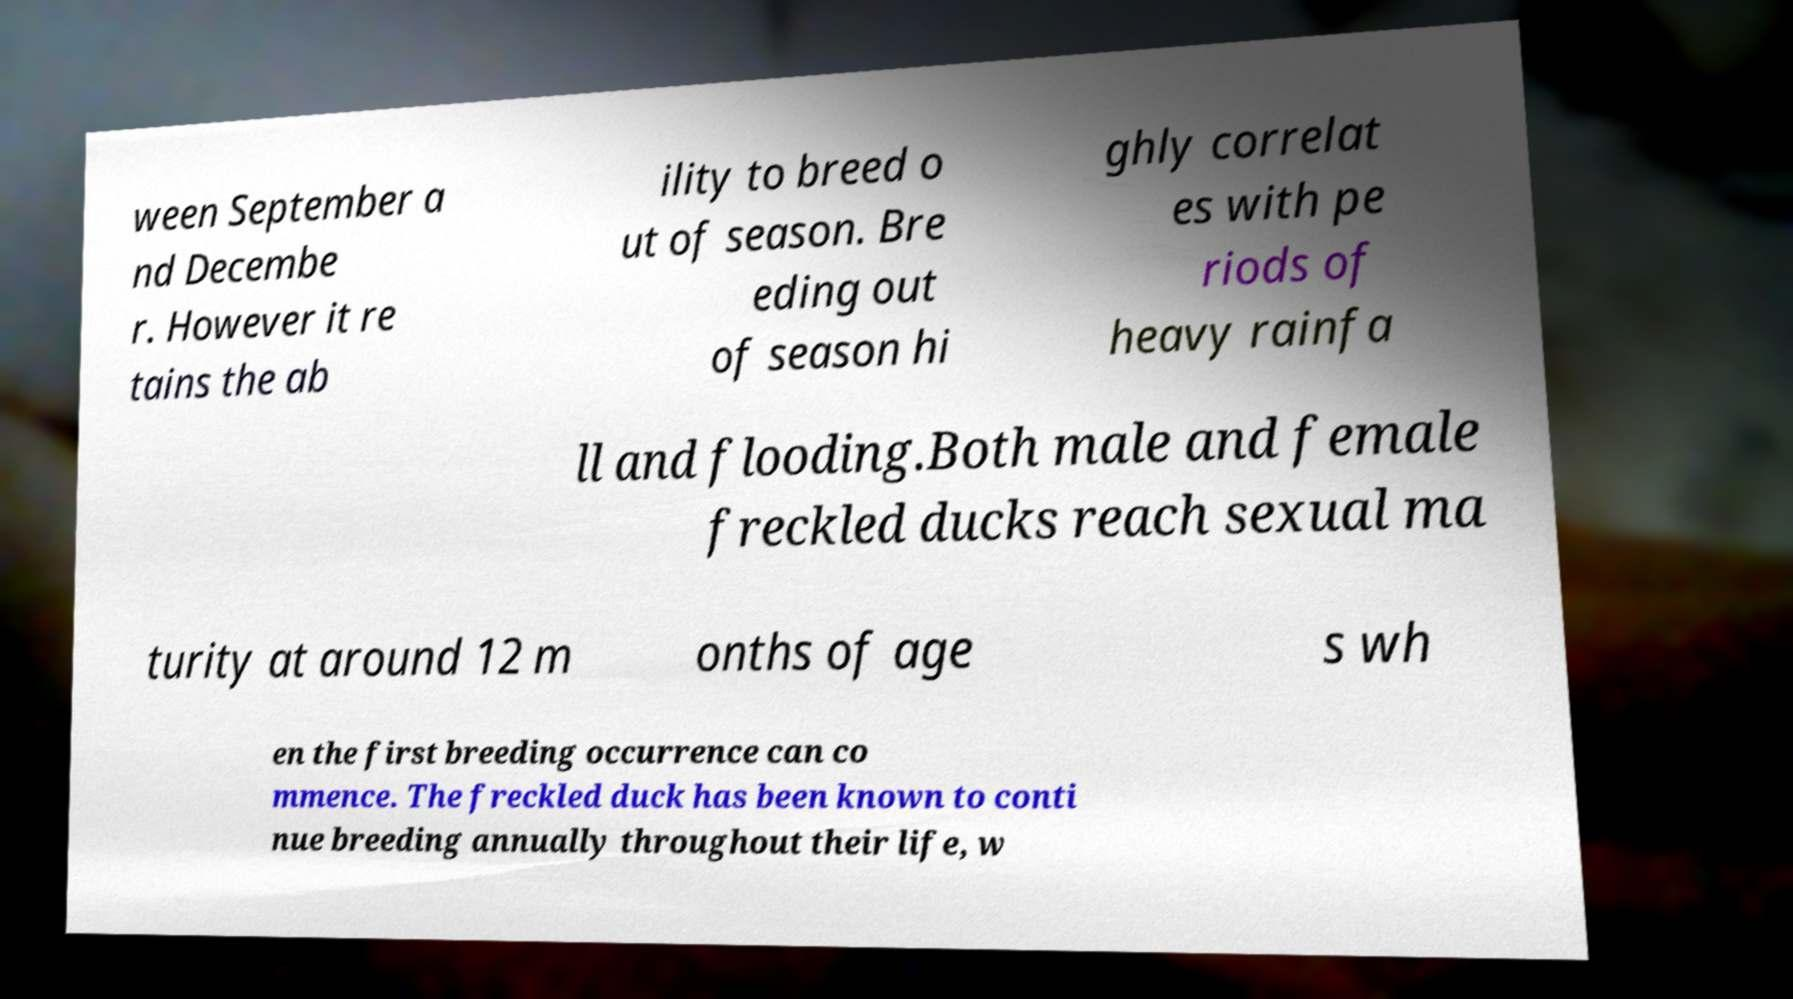Can you accurately transcribe the text from the provided image for me? ween September a nd Decembe r. However it re tains the ab ility to breed o ut of season. Bre eding out of season hi ghly correlat es with pe riods of heavy rainfa ll and flooding.Both male and female freckled ducks reach sexual ma turity at around 12 m onths of age s wh en the first breeding occurrence can co mmence. The freckled duck has been known to conti nue breeding annually throughout their life, w 